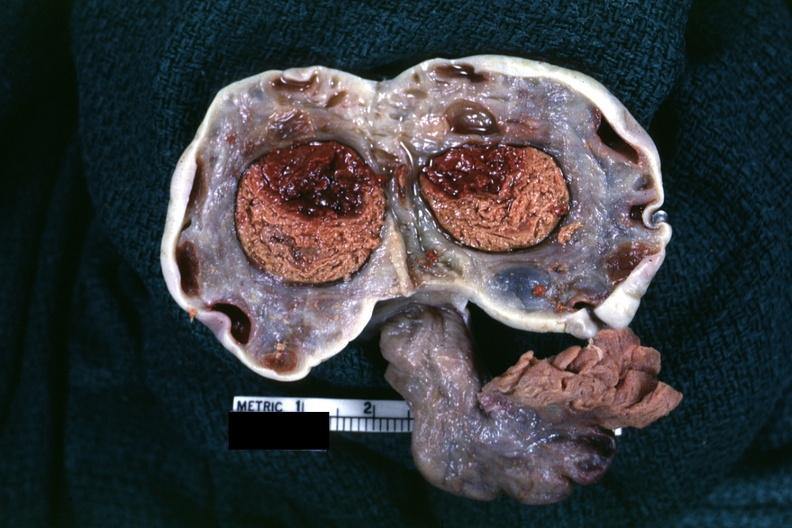what is present?
Answer the question using a single word or phrase. Cyst 